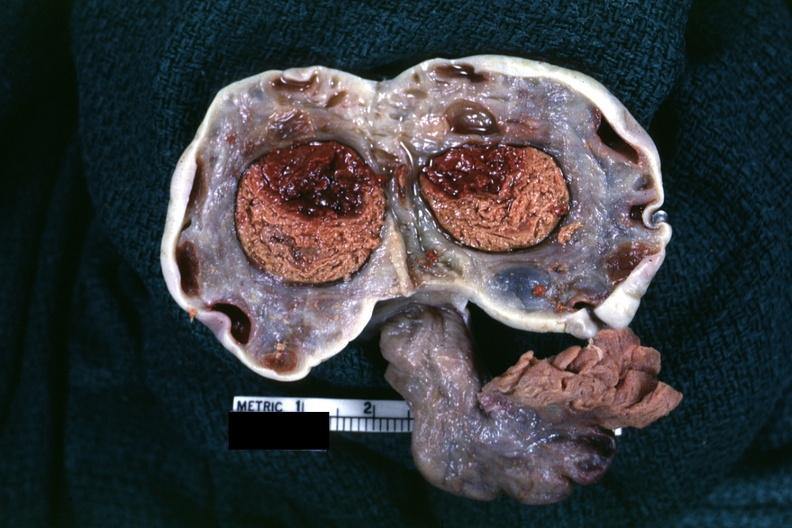what is present?
Answer the question using a single word or phrase. Cyst 